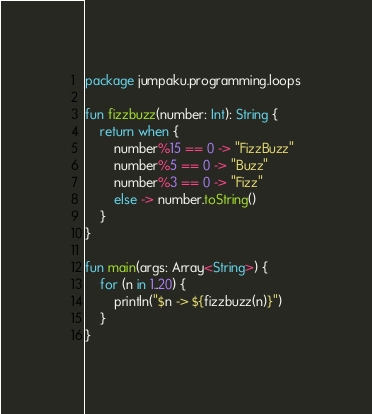<code> <loc_0><loc_0><loc_500><loc_500><_Kotlin_>package jumpaku.programming.loops

fun fizzbuzz(number: Int): String {
    return when {
        number%15 == 0 -> "FizzBuzz"
        number%5 == 0 -> "Buzz"
        number%3 == 0 -> "Fizz"
        else -> number.toString()
    }
}

fun main(args: Array<String>) {
    for (n in 1..20) {
        println("$n -> ${fizzbuzz(n)}")
    }
}</code> 